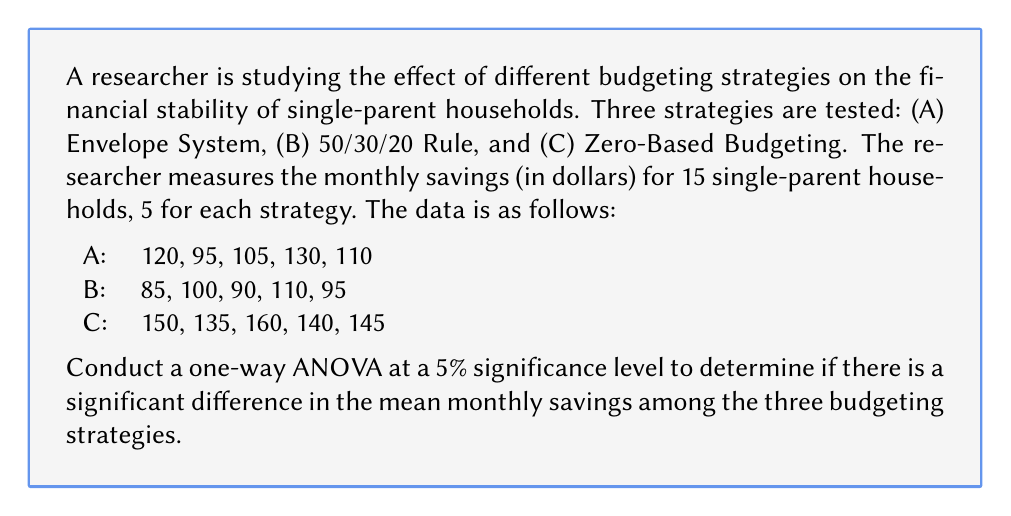Can you solve this math problem? To conduct a one-way ANOVA, we need to follow these steps:

1. Calculate the sum of squares:
   a) Total Sum of Squares (SST)
   b) Between-group Sum of Squares (SSB)
   c) Within-group Sum of Squares (SSW)

2. Calculate the degrees of freedom:
   a) Total (dfT)
   b) Between-group (dfB)
   c) Within-group (dfW)

3. Calculate the Mean Squares:
   a) Between-group (MSB)
   b) Within-group (MSW)

4. Calculate the F-statistic

5. Compare the F-statistic with the critical F-value

Step 1: Calculate the sum of squares

a) Total Sum of Squares (SST):
   $$ SST = \sum_{i=1}^{n} (x_i - \bar{x})^2 $$
   where $x_i$ are individual observations and $\bar{x}$ is the grand mean.
   
   Grand mean: $\bar{x} = \frac{1750}{15} = 116.67$
   
   $SST = 10816.67$

b) Between-group Sum of Squares (SSB):
   $$ SSB = \sum_{i=1}^{k} n_i(\bar{x_i} - \bar{x})^2 $$
   where $k$ is the number of groups, $n_i$ is the number of observations in each group, and $\bar{x_i}$ is the mean of each group.
   
   Group means: $\bar{x_A} = 112$, $\bar{x_B} = 96$, $\bar{x_C} = 146$
   
   $SSB = 5(112 - 116.67)^2 + 5(96 - 116.67)^2 + 5(146 - 116.67)^2 = 7613.33$

c) Within-group Sum of Squares (SSW):
   $$ SSW = SST - SSB $$
   $SSW = 10816.67 - 7613.33 = 3203.34$

Step 2: Calculate the degrees of freedom

a) Total: $dfT = n - 1 = 15 - 1 = 14$
b) Between-group: $dfB = k - 1 = 3 - 1 = 2$
c) Within-group: $dfW = n - k = 15 - 3 = 12$

Step 3: Calculate the Mean Squares

a) Between-group: $MSB = \frac{SSB}{dfB} = \frac{7613.33}{2} = 3806.67$
b) Within-group: $MSW = \frac{SSW}{dfW} = \frac{3203.34}{12} = 266.95$

Step 4: Calculate the F-statistic

$$ F = \frac{MSB}{MSW} = \frac{3806.67}{266.95} = 14.26 $$

Step 5: Compare the F-statistic with the critical F-value

The critical F-value for $\alpha = 0.05$, $dfB = 2$, and $dfW = 12$ is approximately 3.89.

Since the calculated F-statistic (14.26) is greater than the critical F-value (3.89), we reject the null hypothesis.
Answer: Reject the null hypothesis. There is significant evidence at the 5% level to conclude that there are differences in mean monthly savings among the three budgeting strategies for single-parent households (F(2, 12) = 14.26, p < 0.05). 